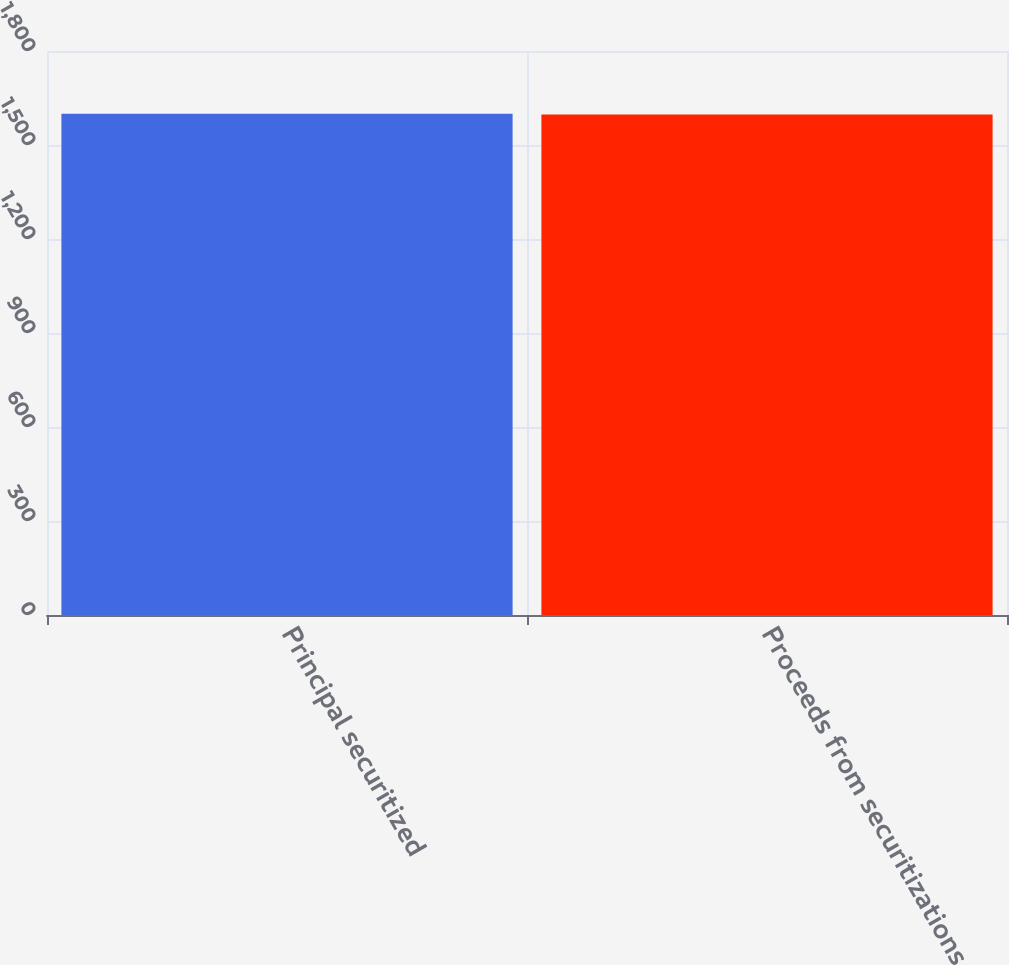<chart> <loc_0><loc_0><loc_500><loc_500><bar_chart><fcel>Principal securitized<fcel>Proceeds from securitizations<nl><fcel>1600<fcel>1597<nl></chart> 